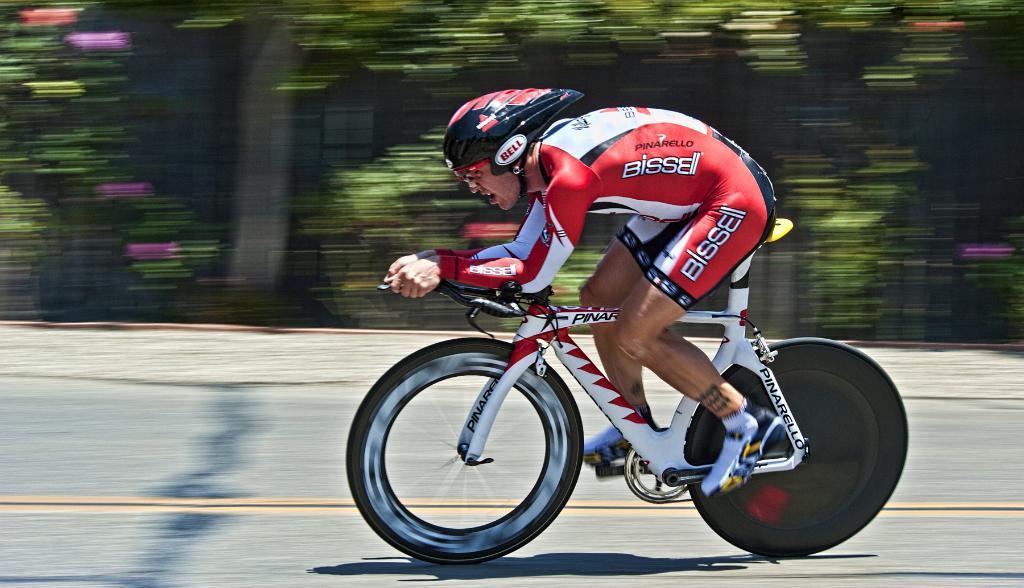How would you summarize this image in a sentence or two? In the center of the image we can see a man riding bicycle on the road. In the background we can see trees. 